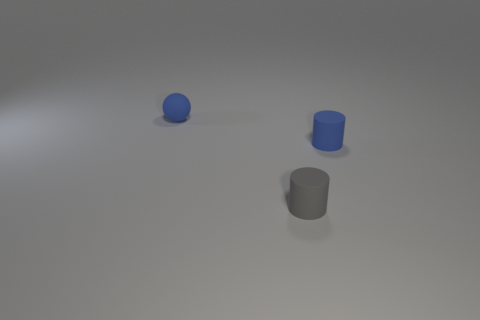Add 3 small blue matte spheres. How many objects exist? 6 Subtract all spheres. How many objects are left? 2 Add 3 cylinders. How many cylinders exist? 5 Subtract 0 brown blocks. How many objects are left? 3 Subtract all blue matte objects. Subtract all blue balls. How many objects are left? 0 Add 2 small gray matte cylinders. How many small gray matte cylinders are left? 3 